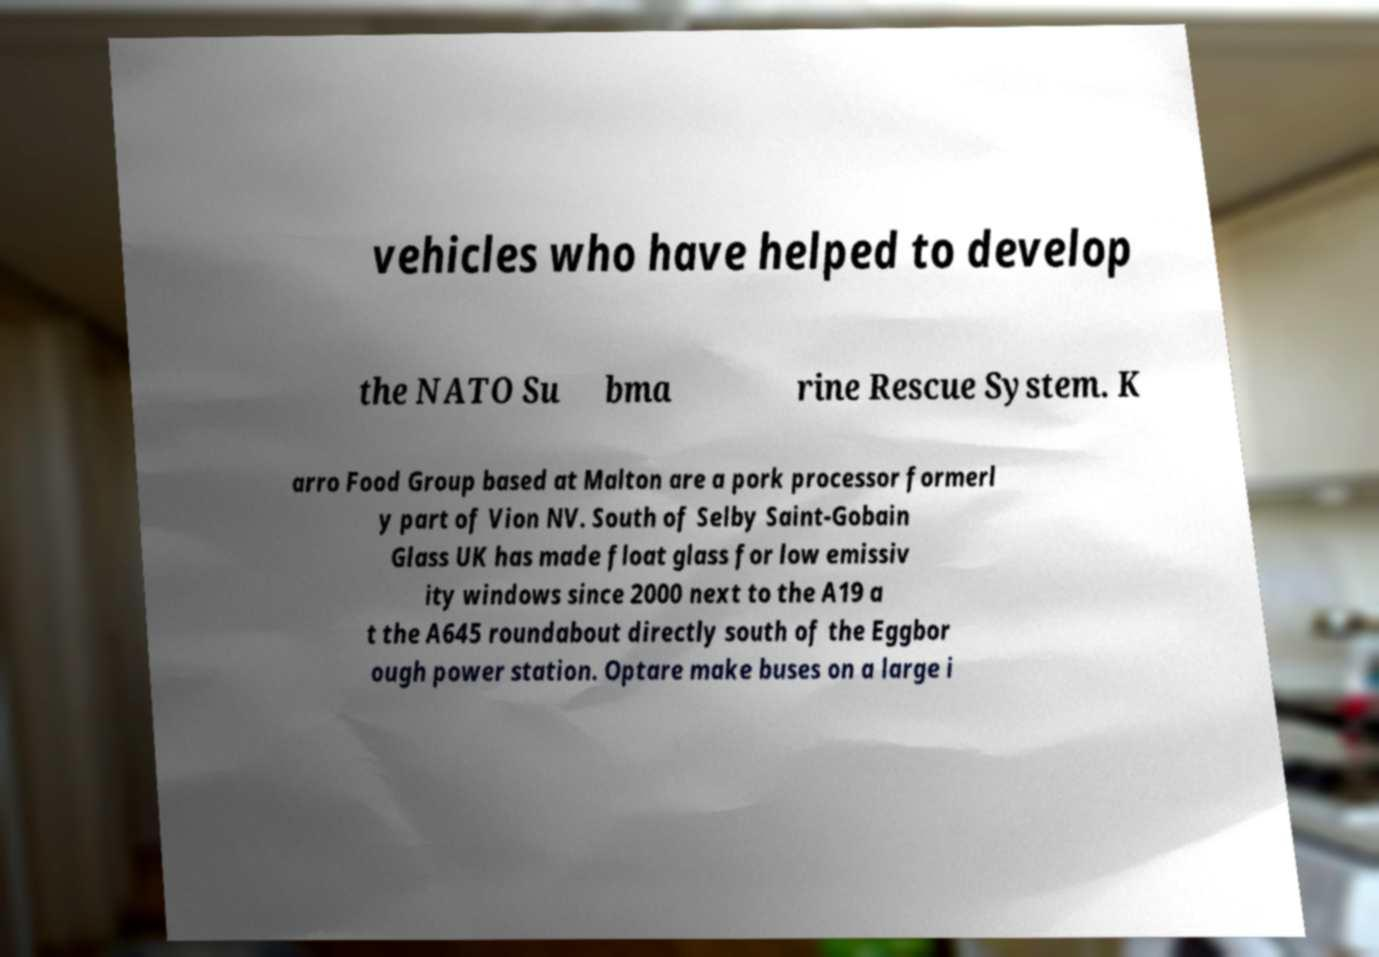For documentation purposes, I need the text within this image transcribed. Could you provide that? vehicles who have helped to develop the NATO Su bma rine Rescue System. K arro Food Group based at Malton are a pork processor formerl y part of Vion NV. South of Selby Saint-Gobain Glass UK has made float glass for low emissiv ity windows since 2000 next to the A19 a t the A645 roundabout directly south of the Eggbor ough power station. Optare make buses on a large i 